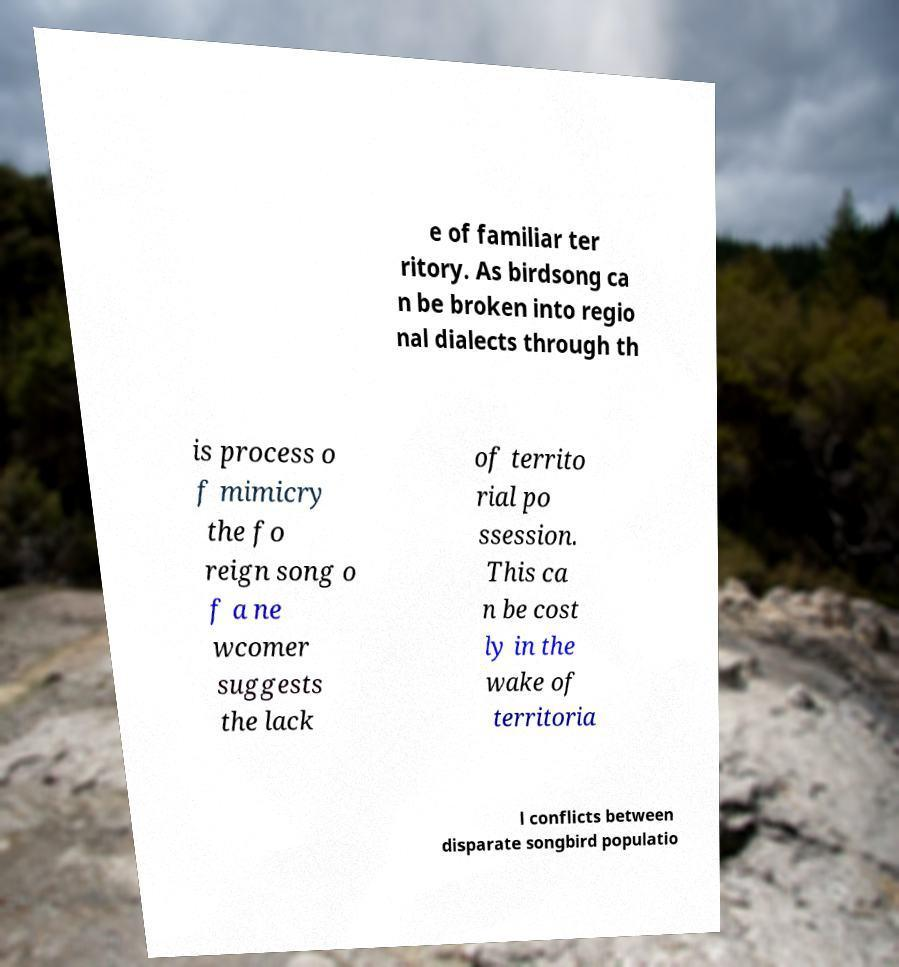What messages or text are displayed in this image? I need them in a readable, typed format. e of familiar ter ritory. As birdsong ca n be broken into regio nal dialects through th is process o f mimicry the fo reign song o f a ne wcomer suggests the lack of territo rial po ssession. This ca n be cost ly in the wake of territoria l conflicts between disparate songbird populatio 